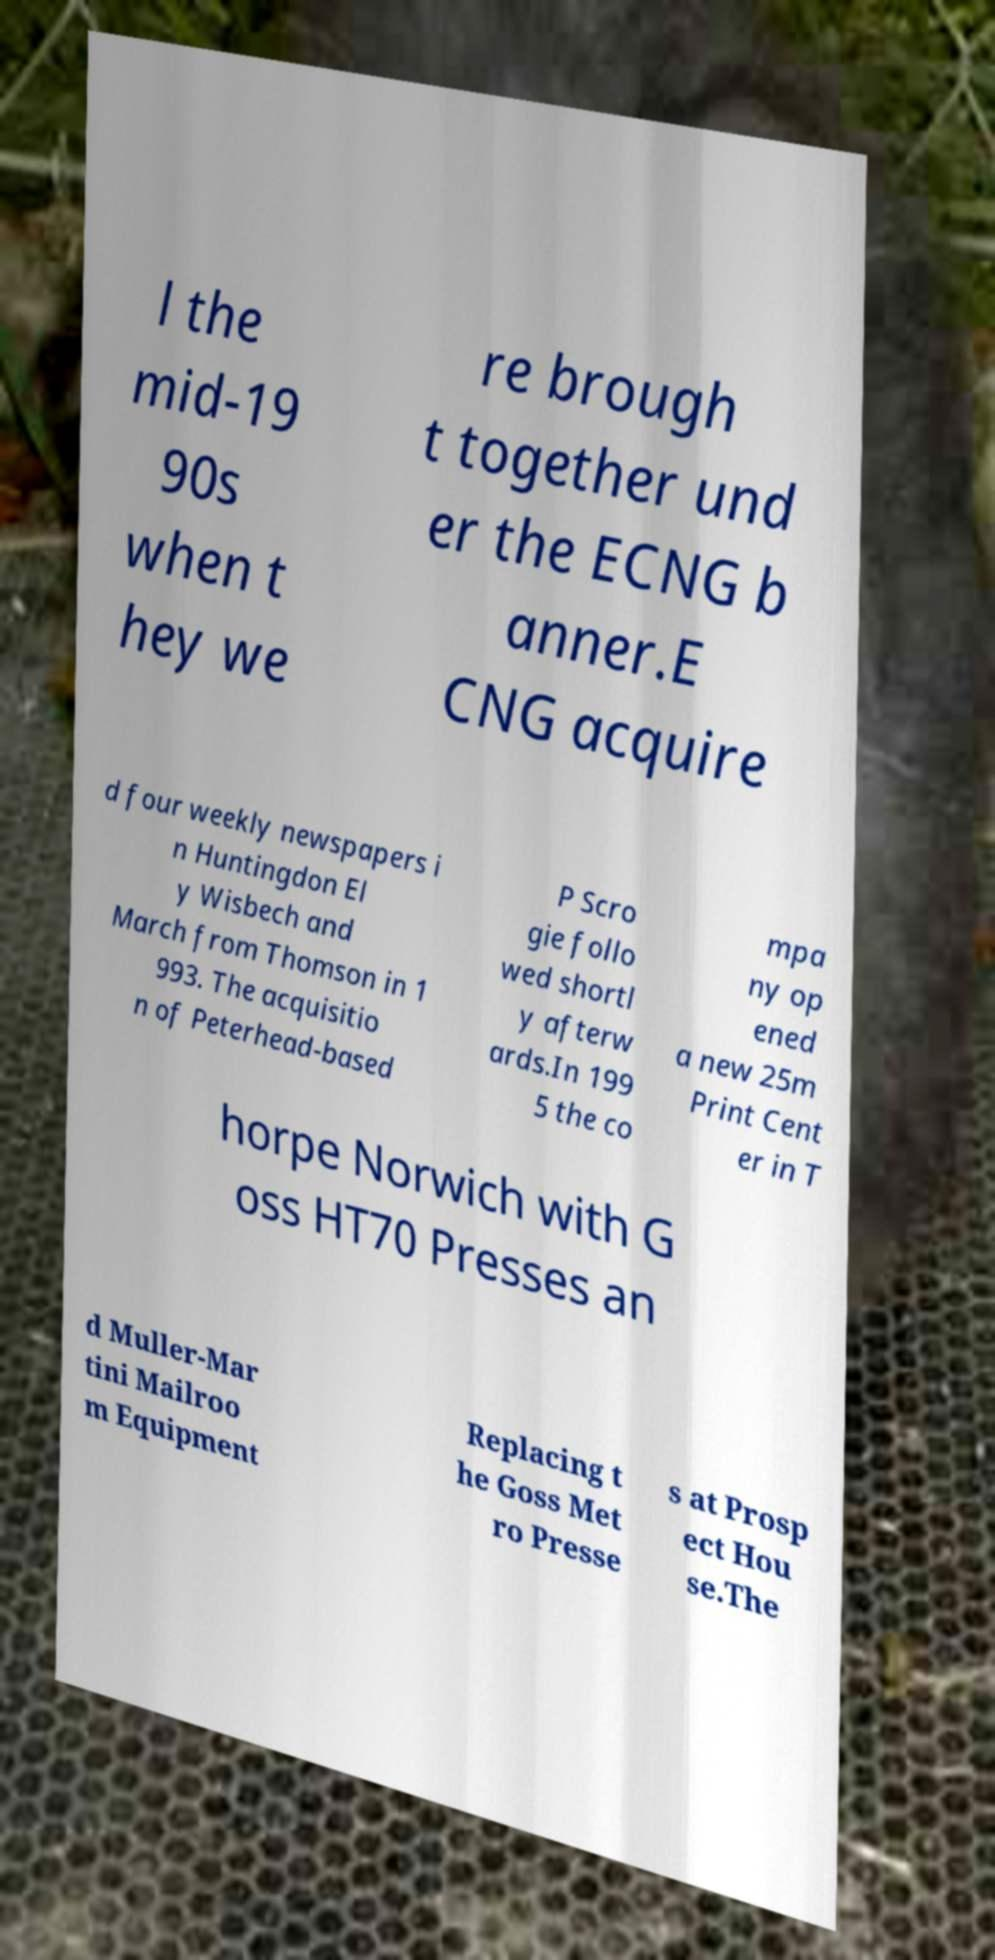Please identify and transcribe the text found in this image. l the mid-19 90s when t hey we re brough t together und er the ECNG b anner.E CNG acquire d four weekly newspapers i n Huntingdon El y Wisbech and March from Thomson in 1 993. The acquisitio n of Peterhead-based P Scro gie follo wed shortl y afterw ards.In 199 5 the co mpa ny op ened a new 25m Print Cent er in T horpe Norwich with G oss HT70 Presses an d Muller-Mar tini Mailroo m Equipment Replacing t he Goss Met ro Presse s at Prosp ect Hou se.The 